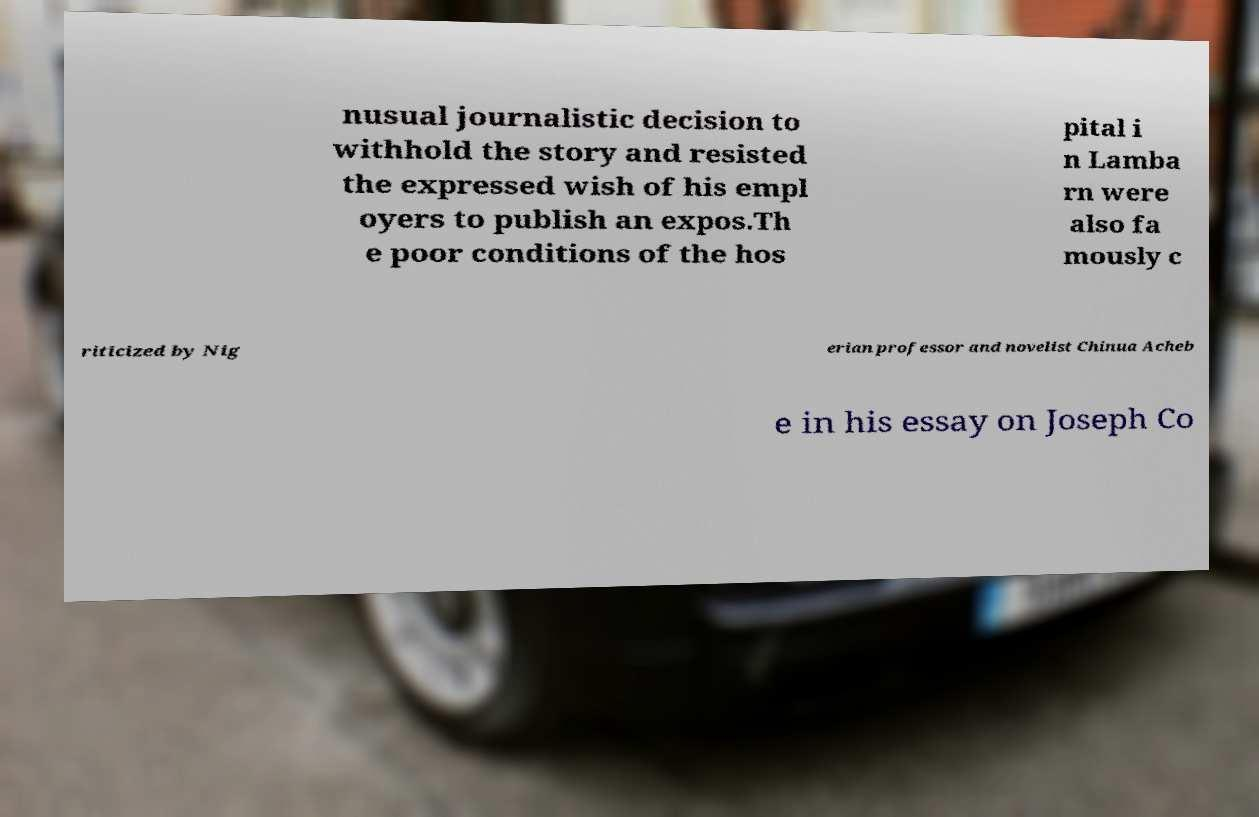I need the written content from this picture converted into text. Can you do that? nusual journalistic decision to withhold the story and resisted the expressed wish of his empl oyers to publish an expos.Th e poor conditions of the hos pital i n Lamba rn were also fa mously c riticized by Nig erian professor and novelist Chinua Acheb e in his essay on Joseph Co 